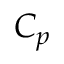Convert formula to latex. <formula><loc_0><loc_0><loc_500><loc_500>C _ { p }</formula> 